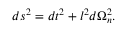<formula> <loc_0><loc_0><loc_500><loc_500>d s ^ { 2 } = d t ^ { 2 } + l ^ { 2 } d \Omega _ { n } ^ { 2 } .</formula> 